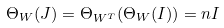<formula> <loc_0><loc_0><loc_500><loc_500>\Theta _ { W } ( J ) = \Theta _ { W ^ { T } } ( \Theta _ { W } ( I ) ) = n I</formula> 